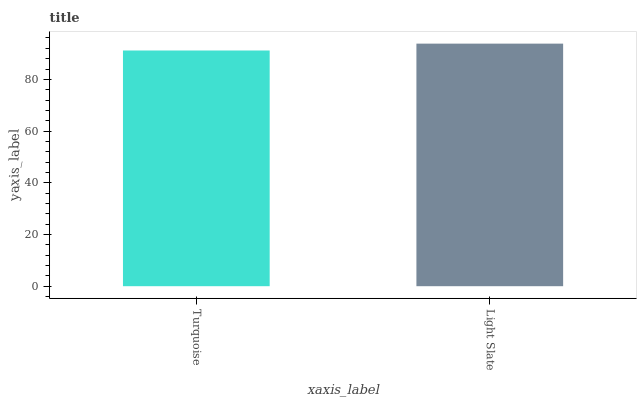Is Turquoise the minimum?
Answer yes or no. Yes. Is Light Slate the maximum?
Answer yes or no. Yes. Is Light Slate the minimum?
Answer yes or no. No. Is Light Slate greater than Turquoise?
Answer yes or no. Yes. Is Turquoise less than Light Slate?
Answer yes or no. Yes. Is Turquoise greater than Light Slate?
Answer yes or no. No. Is Light Slate less than Turquoise?
Answer yes or no. No. Is Light Slate the high median?
Answer yes or no. Yes. Is Turquoise the low median?
Answer yes or no. Yes. Is Turquoise the high median?
Answer yes or no. No. Is Light Slate the low median?
Answer yes or no. No. 